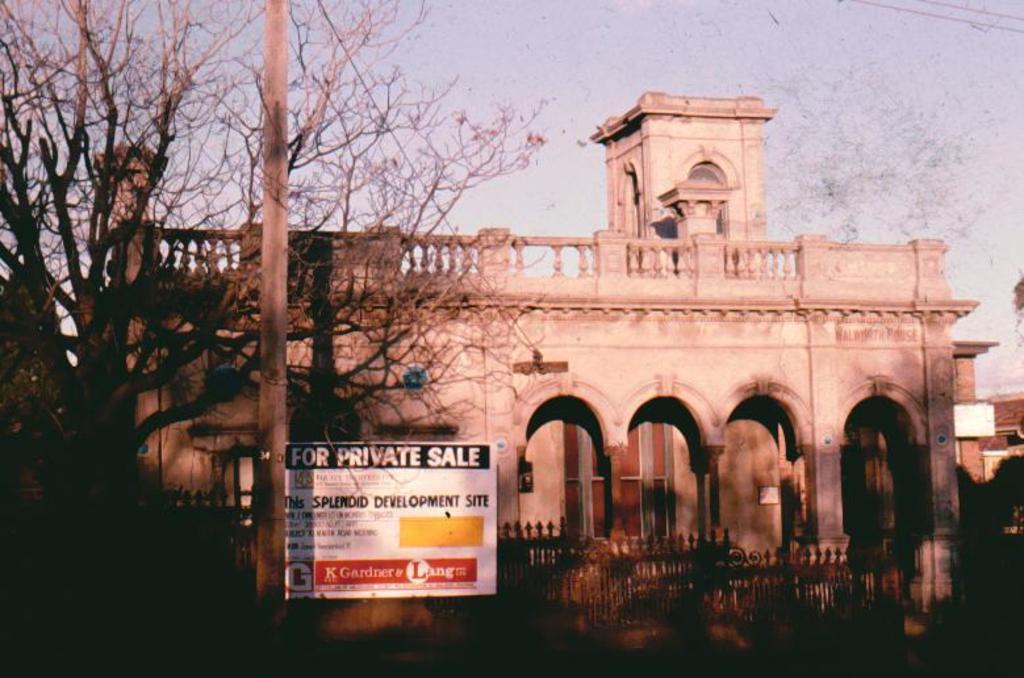Describe this image in one or two sentences. In this picture, we see a pole and a board in white color with some text written on it. At the bottom of the picture, we see a railing. On the left side, we see trees. There are buildings in the background. At the top of the picture, we see the sky. 